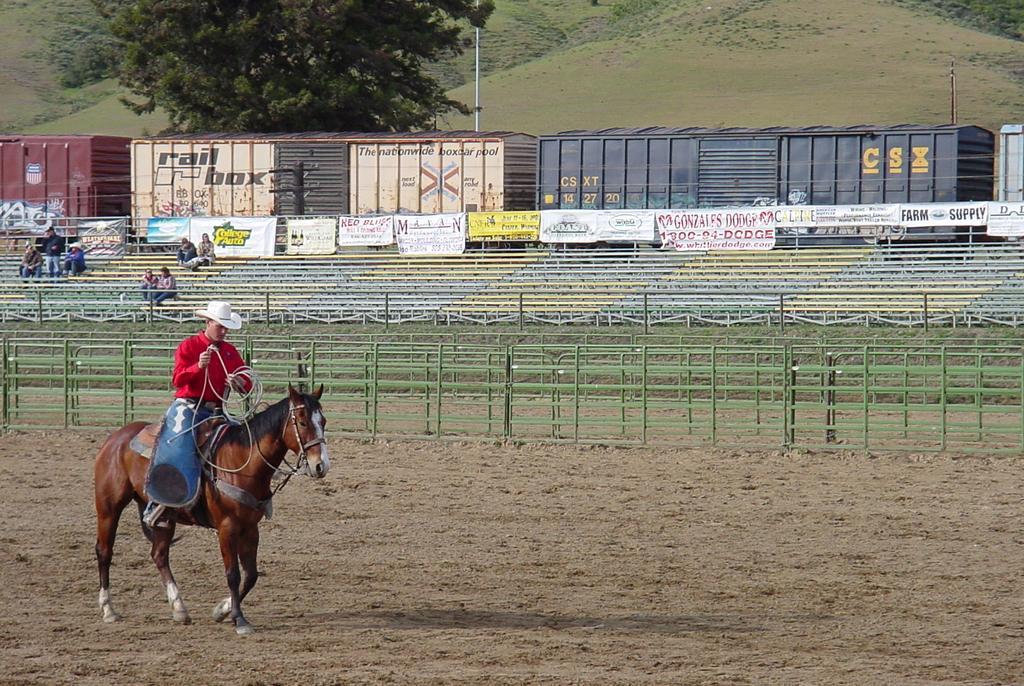How would you summarize this image in a sentence or two? In this image I can see a man is sitting on a brown colour horse. I can see he is holding a rope and I can see he is wearing red colour shirt and white colour hat. In the background I can see Iron bars, few words, a tree, few poles and few more people over there. On these words I can see something is written and I can also see train boxes in the background. 